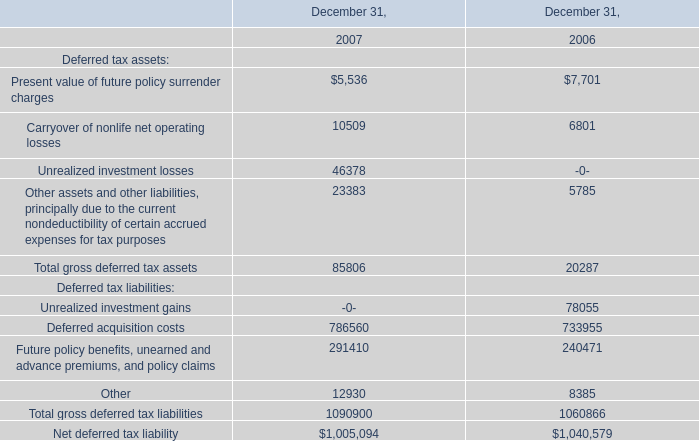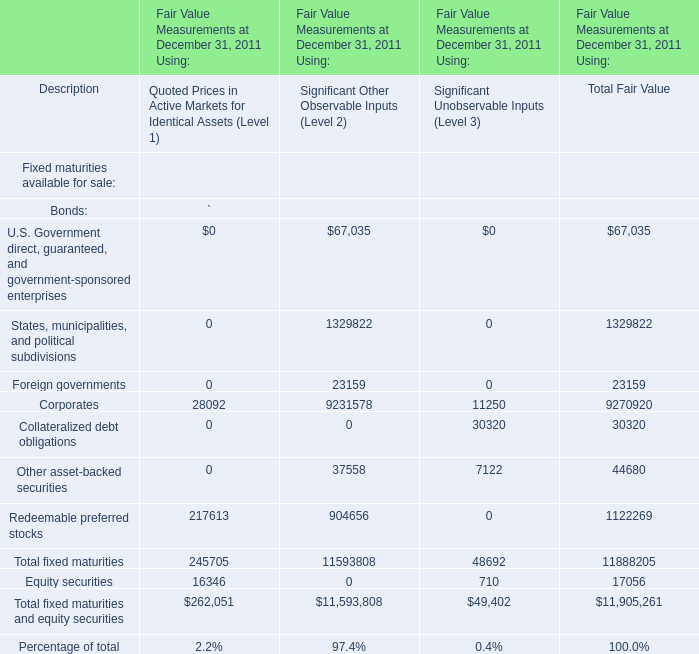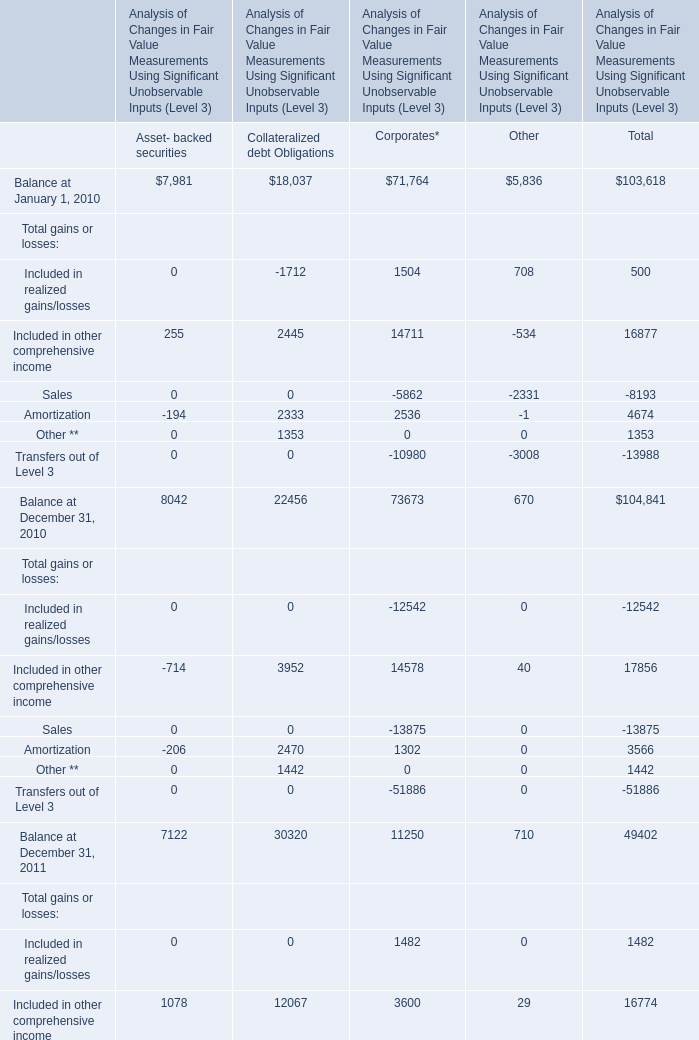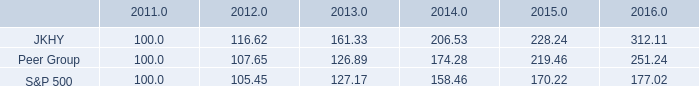What's the 10% of total elements for Total Fair Value in 2011? 
Computations: (11905261 * 0.1)
Answer: 1190526.1. 